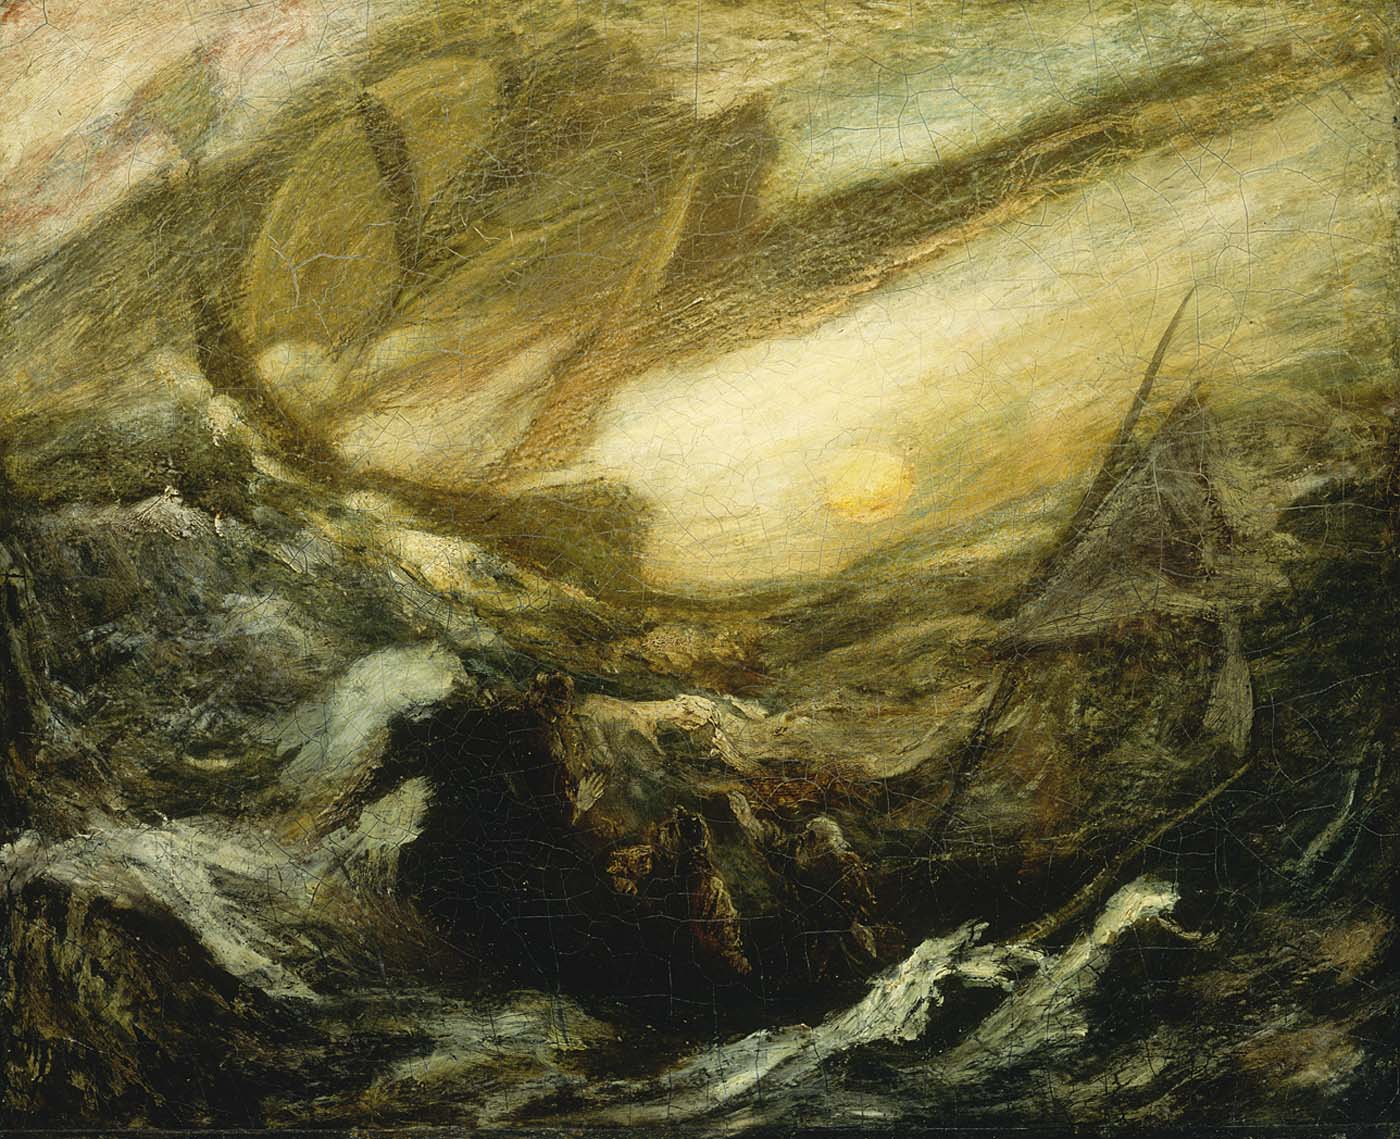If this painting were a scene in a dream, what would it symbolize? In the realm of dreams, this painting could symbolize a journey through the subconscious mind. The roiling ocean represents the depths of our emotions and fears, tumultuous and often uncontrollable. The bright sun piercing through the chaos might signify enlightenment, clarity, or a breakthrough amidst confusion and turmoil. This dream scene could be a call to face one's inner turmoil head-on, suggesting that even in the most chaotic moments, there's always a beacon of hope and understanding waiting to break through. It signifies a transformative journey towards self-awareness and peace. 